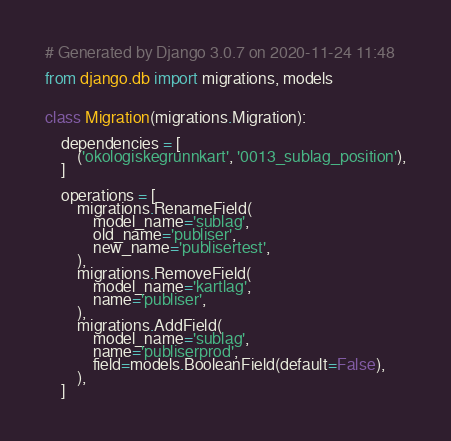Convert code to text. <code><loc_0><loc_0><loc_500><loc_500><_Python_># Generated by Django 3.0.7 on 2020-11-24 11:48

from django.db import migrations, models


class Migration(migrations.Migration):

    dependencies = [
        ('okologiskegrunnkart', '0013_sublag_position'),
    ]

    operations = [
        migrations.RenameField(
            model_name='sublag',
            old_name='publiser',
            new_name='publisertest',
        ),
        migrations.RemoveField(
            model_name='kartlag',
            name='publiser',
        ),
        migrations.AddField(
            model_name='sublag',
            name='publiserprod',
            field=models.BooleanField(default=False),
        ),
    ]
</code> 